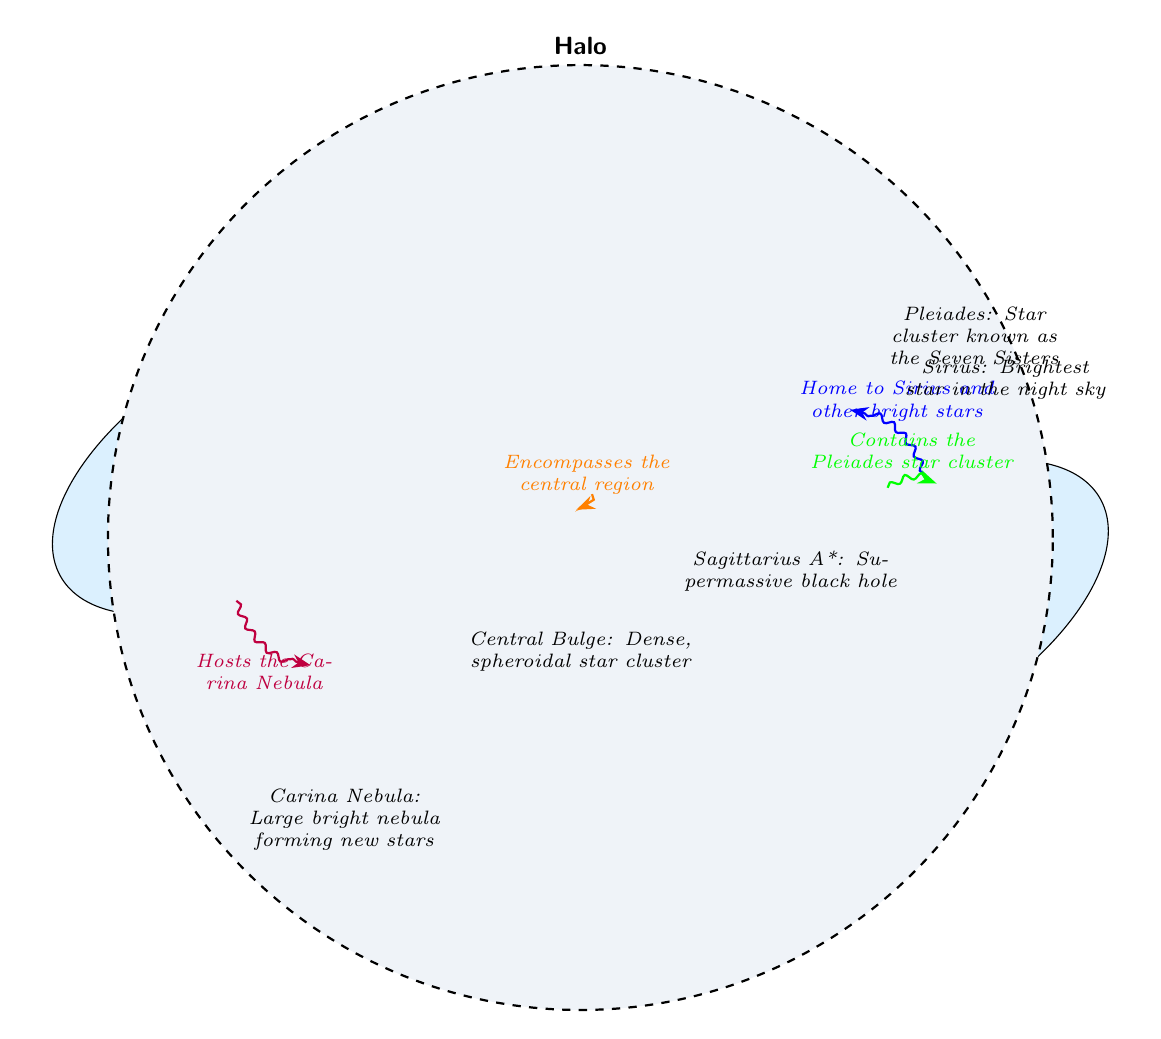What is the central feature of the Milky Way Galaxy? The diagram identifies the Central Bulge (CB) as the central feature, represented with a specific icon with the label CB at the center of the diagram.
Answer: Central Bulge How many spiral arms are labeled in the diagram? The diagram shows and labels two spiral arms: the Orion Arm and the Sagittarius Arm. By counting these labeled arms, we find there are two.
Answer: 2 What star cluster is known as the Seven Sisters? The Pleiades star cluster is labeled in the diagram, and it is commonly referred to as the Seven Sisters. This information is specifically stated in the description.
Answer: Pleiades What significant celestial object is marked at the center of the diagram? The diagram marks Sagittarius A* at the center region (indicated with a label near the central bulge). It is highlighted as a supermassive black hole.
Answer: Sagittarius A* Which nebula is indicated in the lower left corner of the diagram? The diagram identifies the Carina Nebula (labeled CN) positioned in the lower left section, with a description detailing its relevance as a bright nebula.
Answer: Carina Nebula Which is the brightest star depicted in the diagram? Sirius is labeled as the brightest star in the night sky within the diagram. This information is presented close to the star's icon in the upper right area.
Answer: Sirius What does the dashed circle represent in the diagram? The dashed circle is labeled as the Halo, which encompasses the central region of the Milky Way Galaxy, described in the diagram as a surrounding structure.
Answer: Halo How is the Orion Arm related to other nodes in the diagram? The Orion Arm is connected to Sirius and another star cluster (Pleiades) through links that illustrate its position in the galaxy and the notable stars located there based on the arrows and descriptions shown.
Answer: Linked to Sirius and Pleiades What color represents the black hole in the diagram? The color representing the black hole is entirely black with a white text label for Sagittarius A*, indicated in the diagram near the central bulge.
Answer: Black 